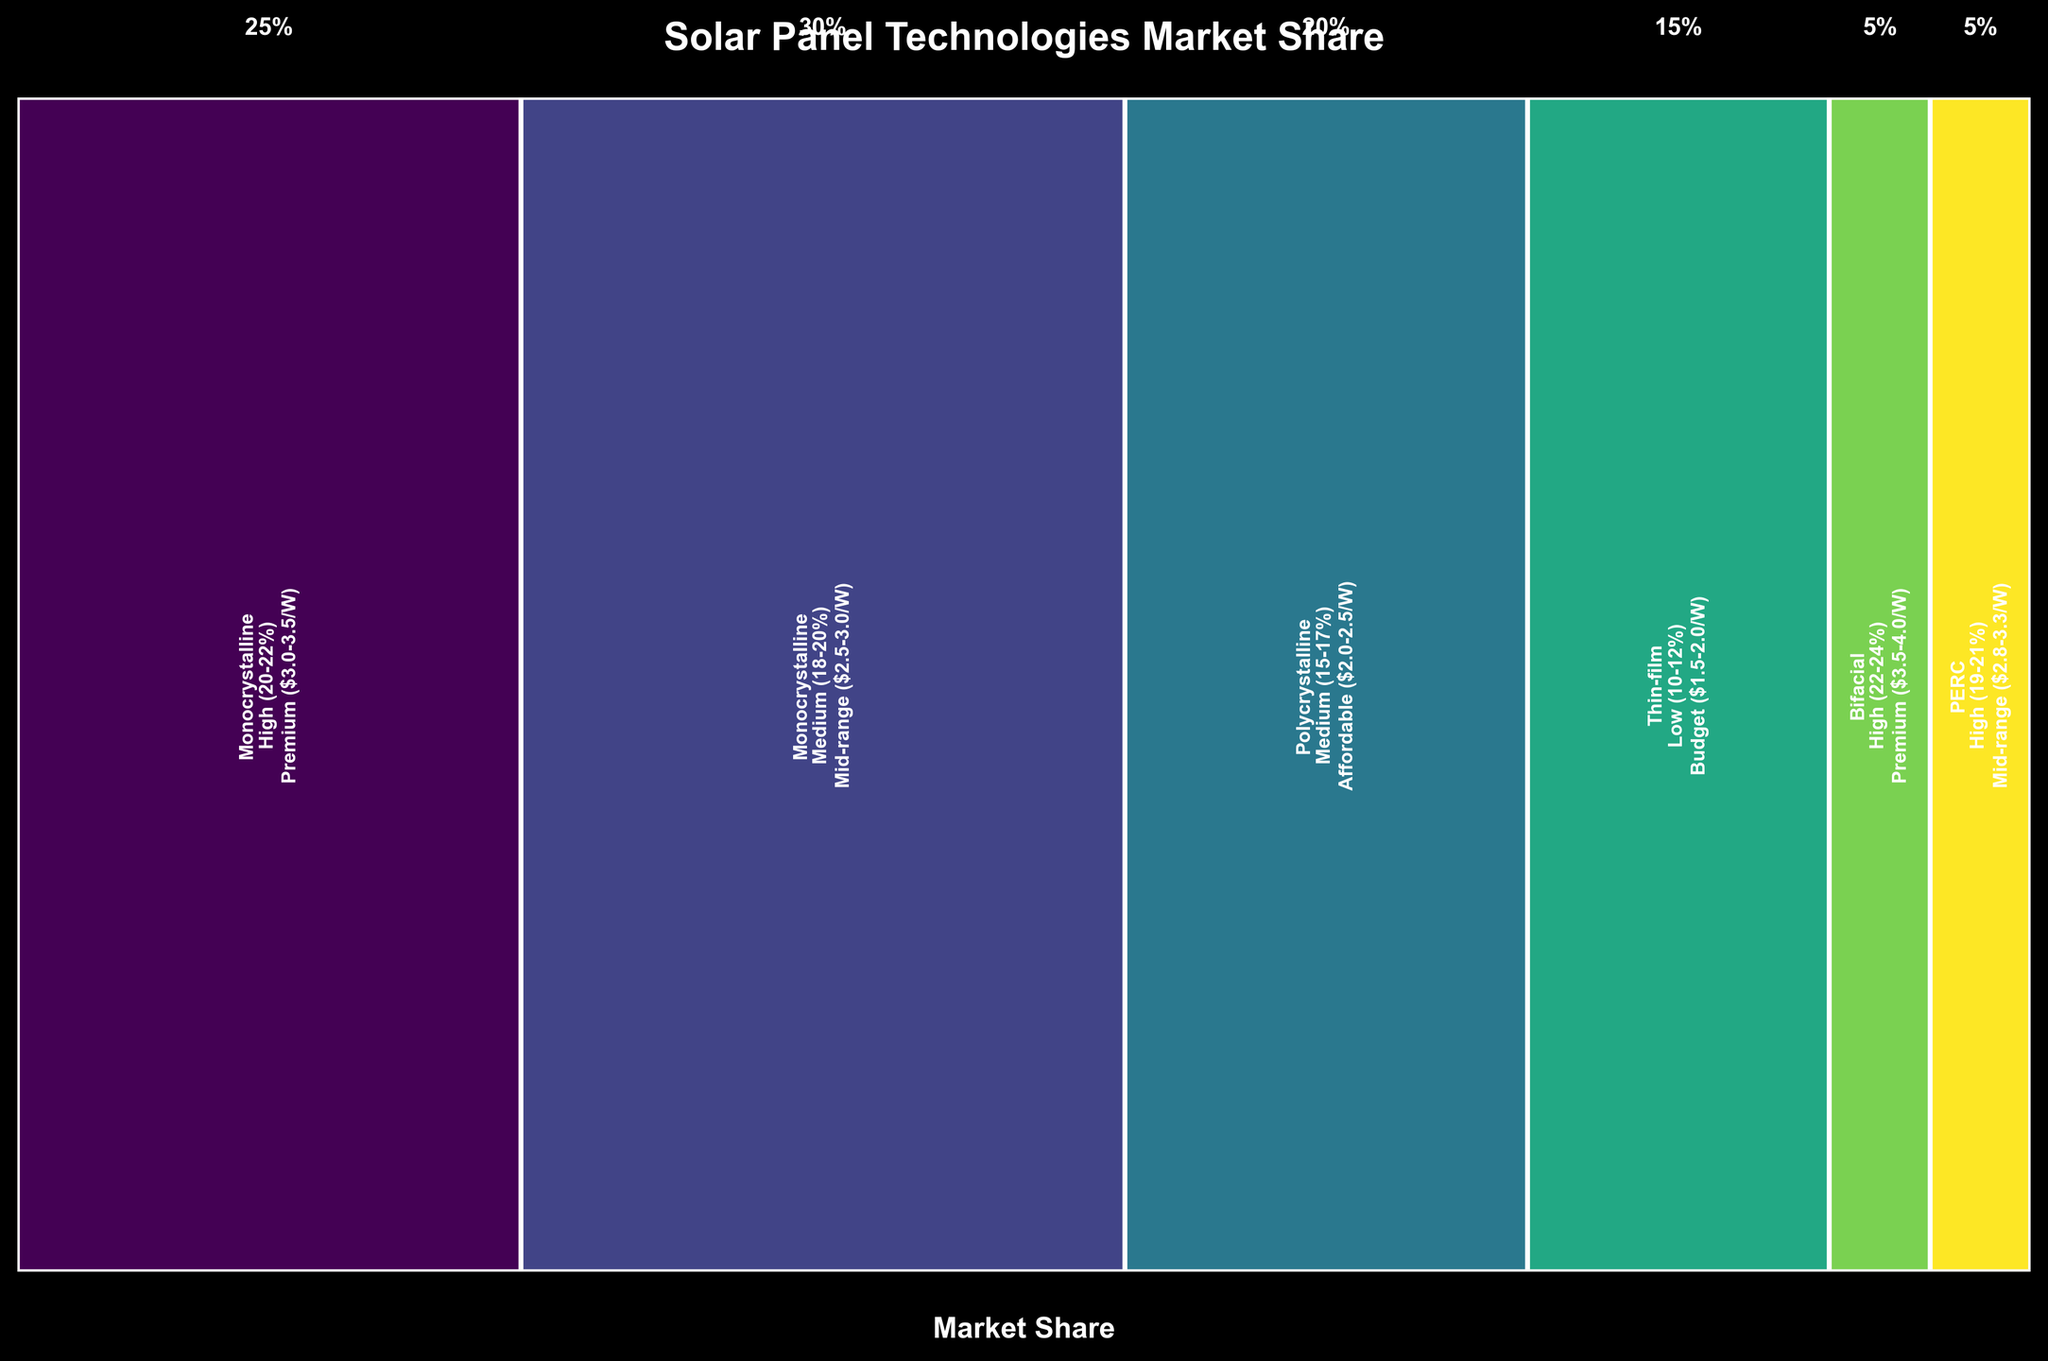What's the title of the figure? The title is typically located at the top of the figure. Here, it reads "Solar Panel Technologies Market Share."
Answer: Solar Panel Technologies Market Share How many different solar panel technologies are illustrated in the figure? Count the distinct labels for the "Technology" attribute displayed within the rectangles. The technologies listed are Monocrystalline, Polycrystalline, Thin-film, Bifacial, and PERC.
Answer: 6 Which solar panel technology has the highest market share? Look for the widest rectangle as width represents market share. Monocrystalline with Medium (18-20%) efficiency and Mid-range ($2.5-3.0/W) price is the widest, indicating the highest market share.
Answer: Monocrystalline (Medium (18-20%), Mid-range ($2.5-3.0/W)) Compare the market shares of Monocrystalline and Thin-film technologies. Which one is larger? Identify the rectangles representing Monocrystalline and Thin-film. Monocrystalline's rectangles are wide, one being 25% and another 30%, while Thin-film's is 15%. Adding the shares of Monocrystalline is larger than Thin-film.
Answer: Monocrystalline What is the combined market share of high-efficiency solar panel technologies? Sum the market shares of technologies marked as high efficiency: Monocrystalline High (25%), Bifacial High (5%), and PERC High (5%). The total is 25 + 5 + 5.
Answer: 35% Which price category has the highest total market share? Sum market shares for each price category: Premium (25 + 5 = 30%), Mid-range (30 + 5 = 35%), Affordable (20%), and Budget (15%). The Mid-range category has the highest share.
Answer: Mid-range How does the market share of Polycrystalline panels compare to PERC panels? Polycrystalline panels have a share of 20%, while PERC panels have a share of 5%. Polycrystalline panels have a larger market share.
Answer: Polycrystalline is larger Which technology and efficiency rating combination has the least market share? Identify the smallest rectangle. Bifacial with High (22-24%) efficiency and Premium ($3.5-4.0/W) price has a market share of 5%, same as PERC. However, within the high-efficiency category, Bifacial stands out.
Answer: Bifacial (High (22-24%), Premium ($3.5-4.0/W)) How does the efficiency range affect the market share of Monocrystalline panels? Compare market shares of Monocrystalline panels: High efficiency (25%) and Medium efficiency (30%). Medium efficiency panels have a higher market share than high-efficiency panels.
Answer: Medium efficiency has higher share 